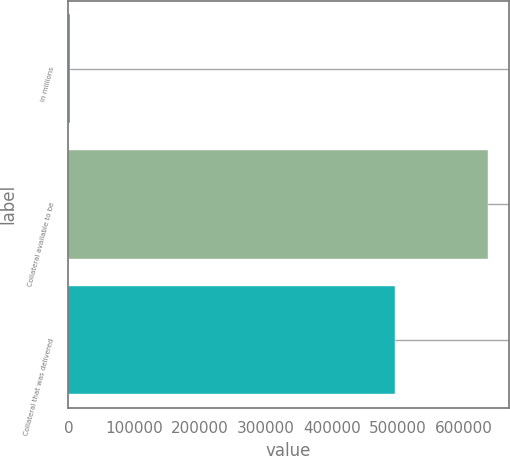Convert chart to OTSL. <chart><loc_0><loc_0><loc_500><loc_500><bar_chart><fcel>in millions<fcel>Collateral available to be<fcel>Collateral that was delivered<nl><fcel>2015<fcel>636684<fcel>496240<nl></chart> 